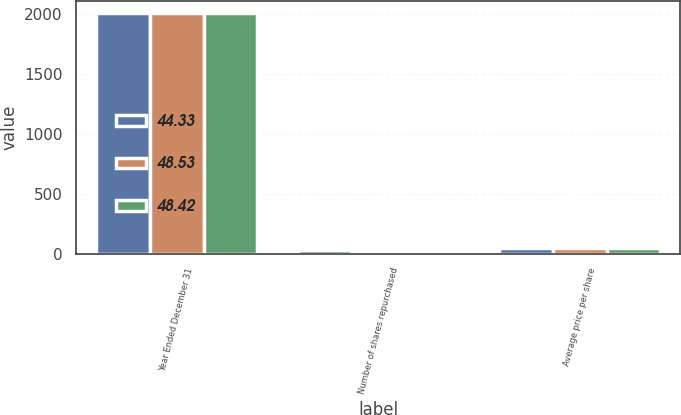<chart> <loc_0><loc_0><loc_500><loc_500><stacked_bar_chart><ecel><fcel>Year Ended December 31<fcel>Number of shares repurchased<fcel>Average price per share<nl><fcel>44.33<fcel>2003<fcel>33<fcel>44.33<nl><fcel>48.53<fcel>2002<fcel>14<fcel>48.42<nl><fcel>48.42<fcel>2001<fcel>5<fcel>48.53<nl></chart> 